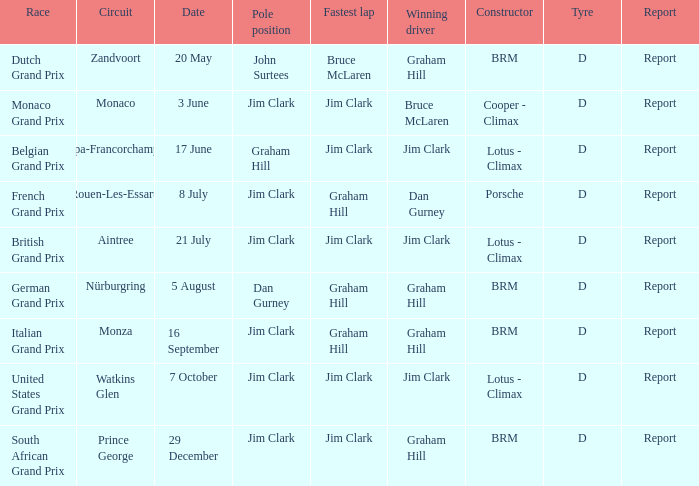What is the constructor at the United States Grand Prix? Lotus - Climax. Can you parse all the data within this table? {'header': ['Race', 'Circuit', 'Date', 'Pole position', 'Fastest lap', 'Winning driver', 'Constructor', 'Tyre', 'Report'], 'rows': [['Dutch Grand Prix', 'Zandvoort', '20 May', 'John Surtees', 'Bruce McLaren', 'Graham Hill', 'BRM', 'D', 'Report'], ['Monaco Grand Prix', 'Monaco', '3 June', 'Jim Clark', 'Jim Clark', 'Bruce McLaren', 'Cooper - Climax', 'D', 'Report'], ['Belgian Grand Prix', 'Spa-Francorchamps', '17 June', 'Graham Hill', 'Jim Clark', 'Jim Clark', 'Lotus - Climax', 'D', 'Report'], ['French Grand Prix', 'Rouen-Les-Essarts', '8 July', 'Jim Clark', 'Graham Hill', 'Dan Gurney', 'Porsche', 'D', 'Report'], ['British Grand Prix', 'Aintree', '21 July', 'Jim Clark', 'Jim Clark', 'Jim Clark', 'Lotus - Climax', 'D', 'Report'], ['German Grand Prix', 'Nürburgring', '5 August', 'Dan Gurney', 'Graham Hill', 'Graham Hill', 'BRM', 'D', 'Report'], ['Italian Grand Prix', 'Monza', '16 September', 'Jim Clark', 'Graham Hill', 'Graham Hill', 'BRM', 'D', 'Report'], ['United States Grand Prix', 'Watkins Glen', '7 October', 'Jim Clark', 'Jim Clark', 'Jim Clark', 'Lotus - Climax', 'D', 'Report'], ['South African Grand Prix', 'Prince George', '29 December', 'Jim Clark', 'Jim Clark', 'Graham Hill', 'BRM', 'D', 'Report']]} 